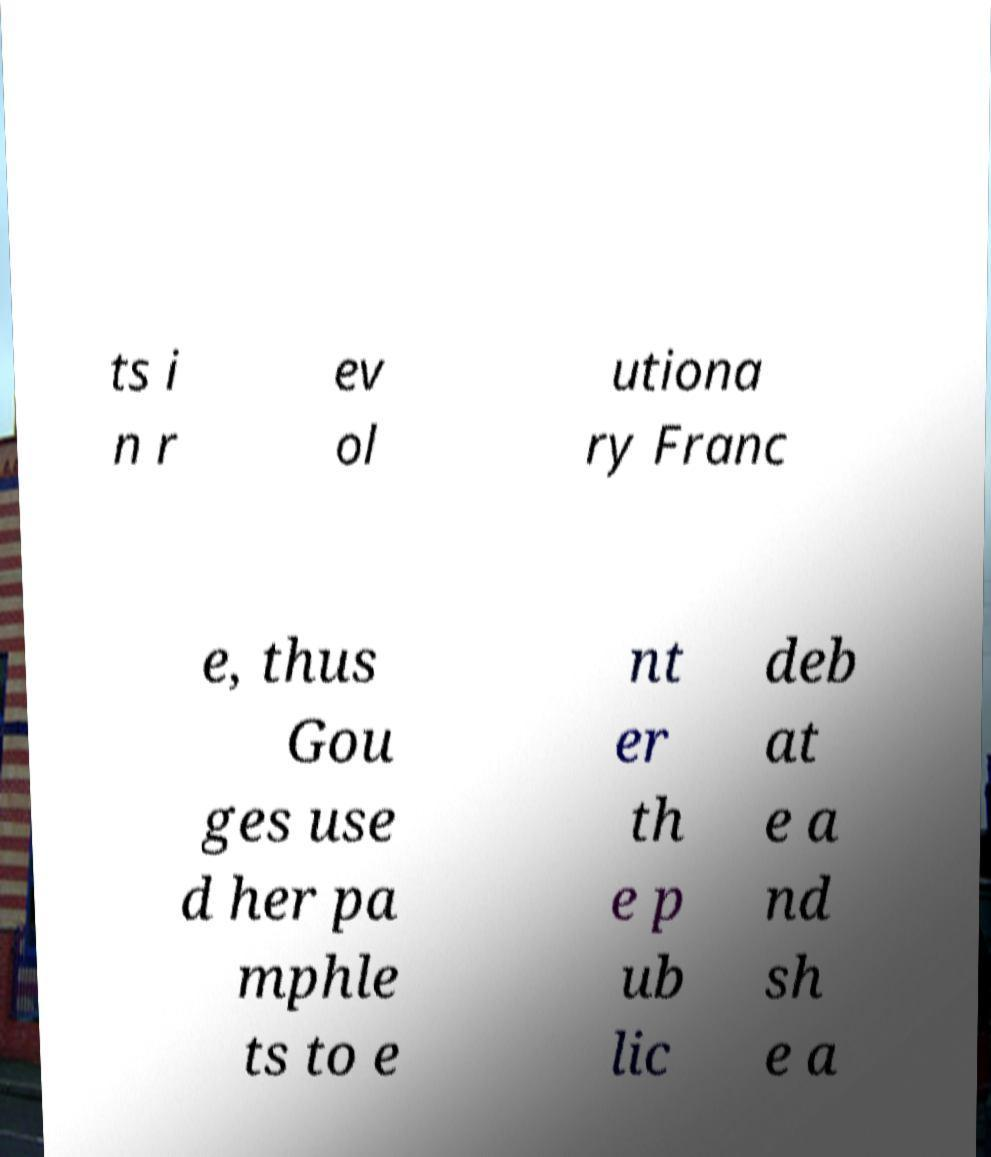Could you assist in decoding the text presented in this image and type it out clearly? ts i n r ev ol utiona ry Franc e, thus Gou ges use d her pa mphle ts to e nt er th e p ub lic deb at e a nd sh e a 